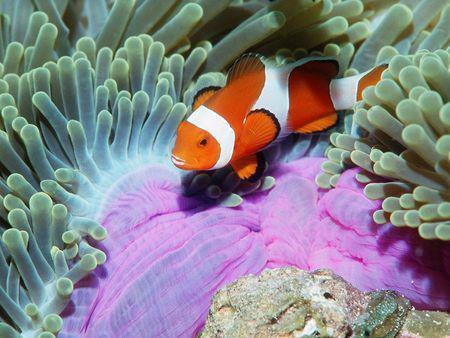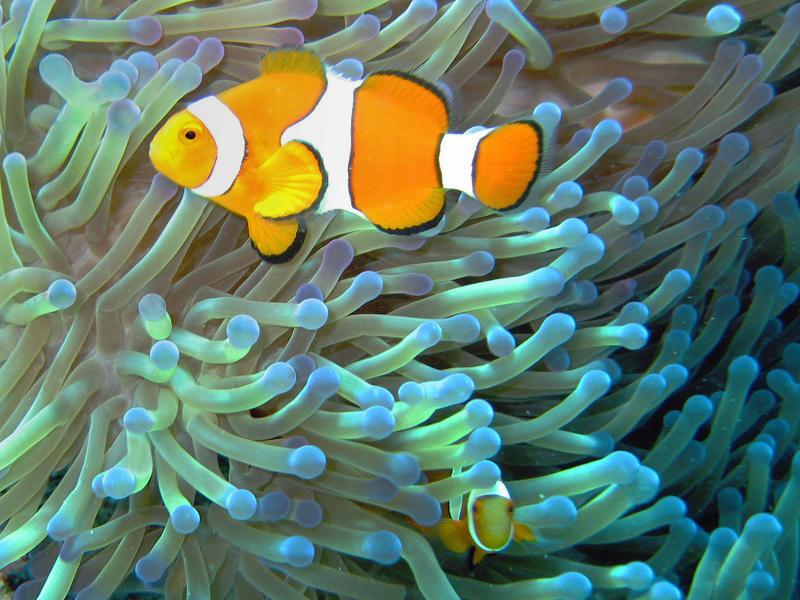The first image is the image on the left, the second image is the image on the right. Examine the images to the left and right. Is the description "One image shows exactly three orange-and-white clown fish swimming by an anemone." accurate? Answer yes or no. No. 